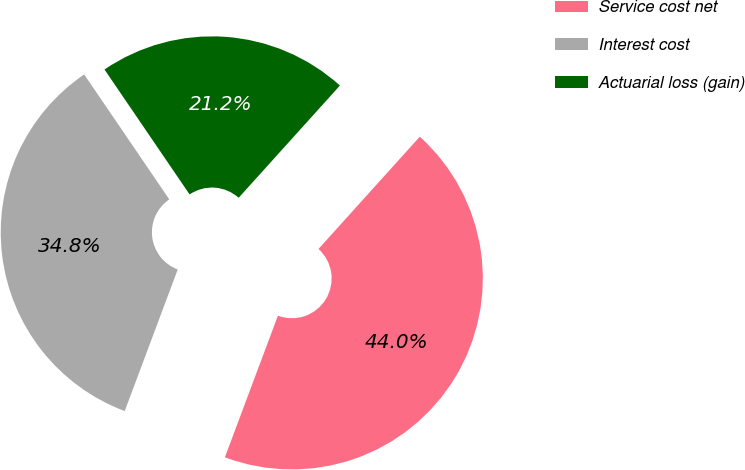Convert chart to OTSL. <chart><loc_0><loc_0><loc_500><loc_500><pie_chart><fcel>Service cost net<fcel>Interest cost<fcel>Actuarial loss (gain)<nl><fcel>44.02%<fcel>34.78%<fcel>21.2%<nl></chart> 